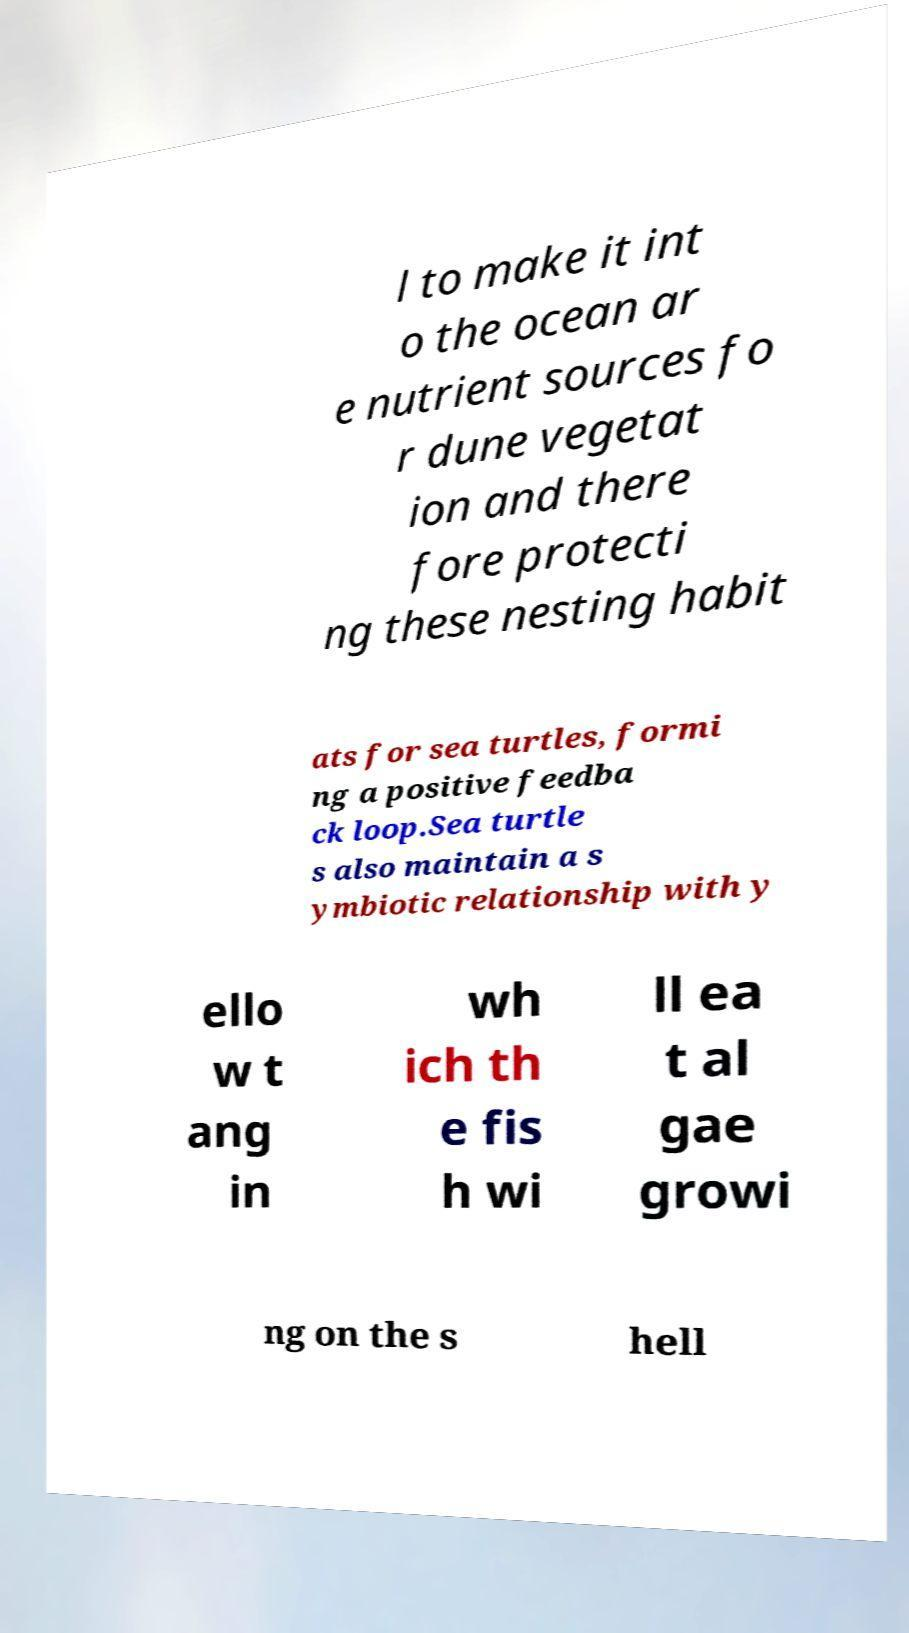Please identify and transcribe the text found in this image. l to make it int o the ocean ar e nutrient sources fo r dune vegetat ion and there fore protecti ng these nesting habit ats for sea turtles, formi ng a positive feedba ck loop.Sea turtle s also maintain a s ymbiotic relationship with y ello w t ang in wh ich th e fis h wi ll ea t al gae growi ng on the s hell 